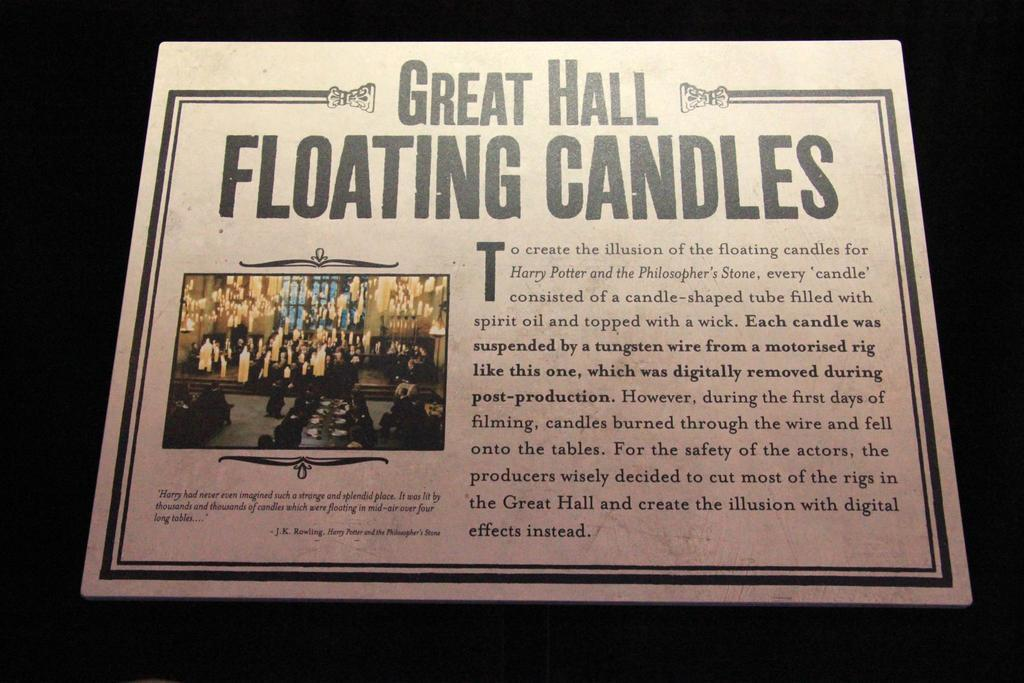Provide a one-sentence caption for the provided image. A cardboard card filled with information regarding the filming of the first Harry Potter Film. 